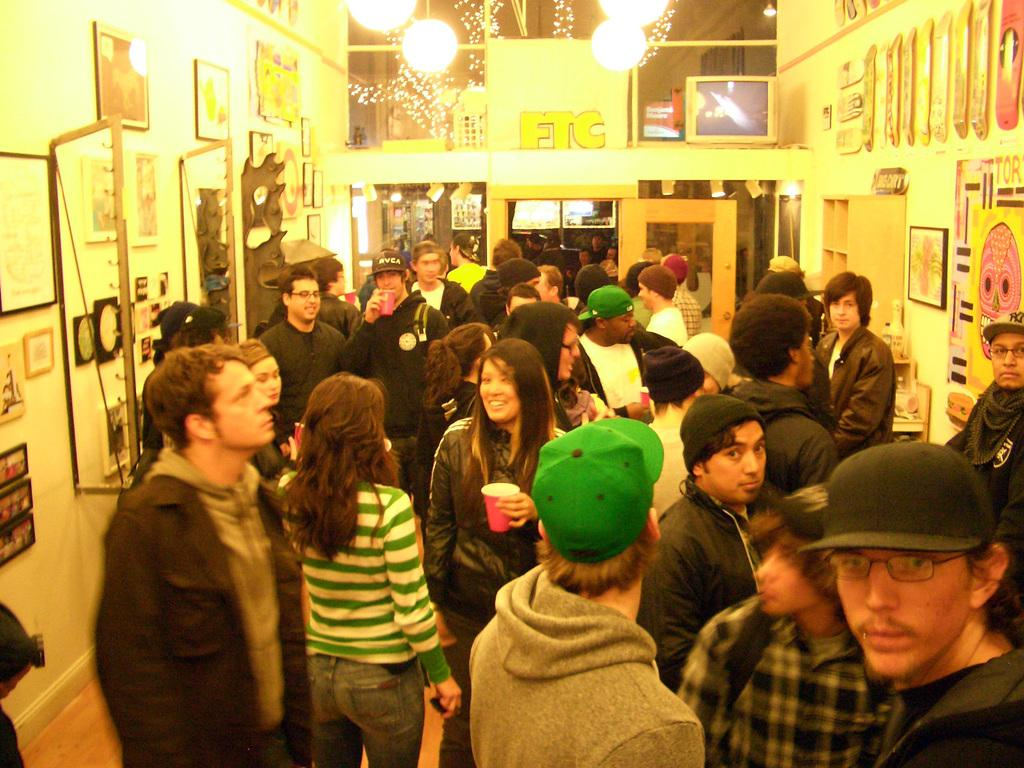How many people are present in the room in the image? There are many people in the room in the image. What can be seen on the wall in the background? There are photographs fitted to the wall in the background. What is attached to the roof in the image? There are lights attached to the roof in the image. How many parts of the eye can be seen in the image? There are no visible parts of the eye in the image; it focuses on people, photographs, and lights. 